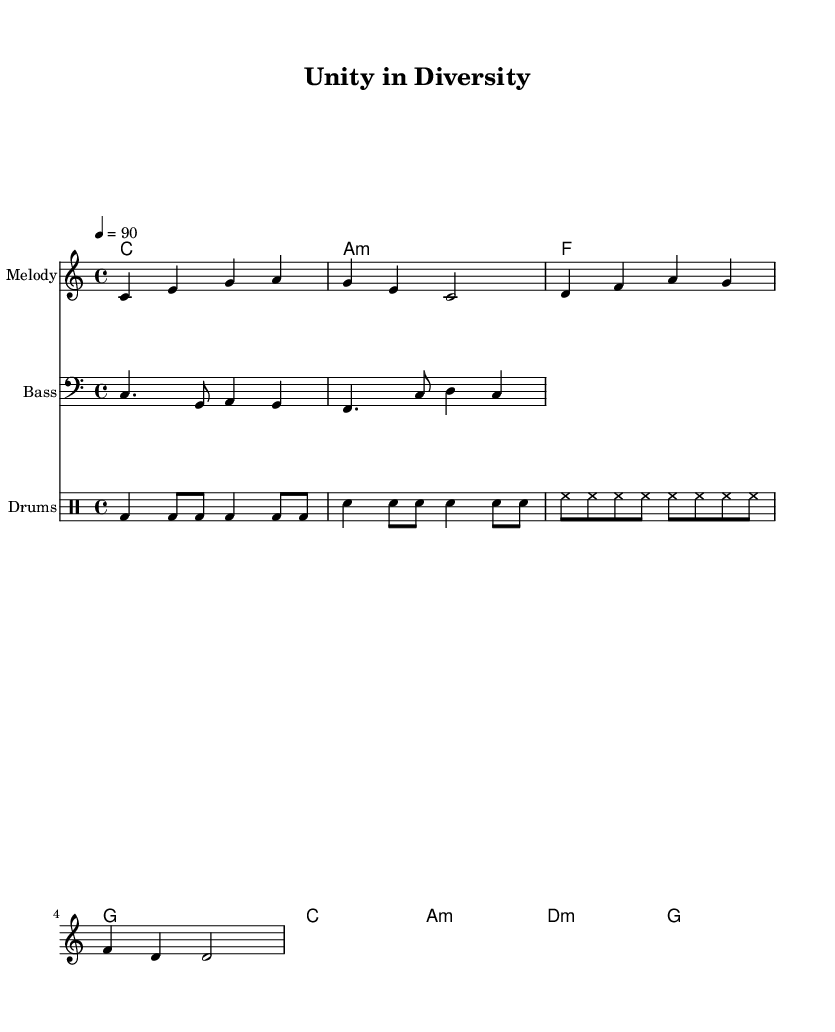What is the key signature of this music? The key signature is C major, which has no sharps or flats, as indicated at the beginning of the score.
Answer: C major What is the time signature of the piece? The time signature is shown at the beginning of the score as 4/4, which means four beats per measure, with each quarter note receiving one beat.
Answer: 4/4 What is the tempo marked in the score? The tempo is indicated as 4 = 90, meaning the piece should be played at 90 beats per minute, setting a moderately upbeat pace typical for reggae music.
Answer: 90 How many measures does the melody have? The melody consists of two measures, which can be counted based on the grouping of notes and the vertical lines in the sheet music that separate the measures.
Answer: 2 What style is this music classified as? The sheet music is specified as "Reggae-fusion," indicating a blend of reggae with other musical styles, hinting at its unique rhythmic elements and collaborative nature in its lyrics.
Answer: Reggae-fusion What is the main theme of the lyrics? The lyrics focus on collaboration and unity by referencing diverse fields and the coming together of knowledge, skills, and data, which is central to interdisciplinary efforts.
Answer: Interdisciplinary collaboration 